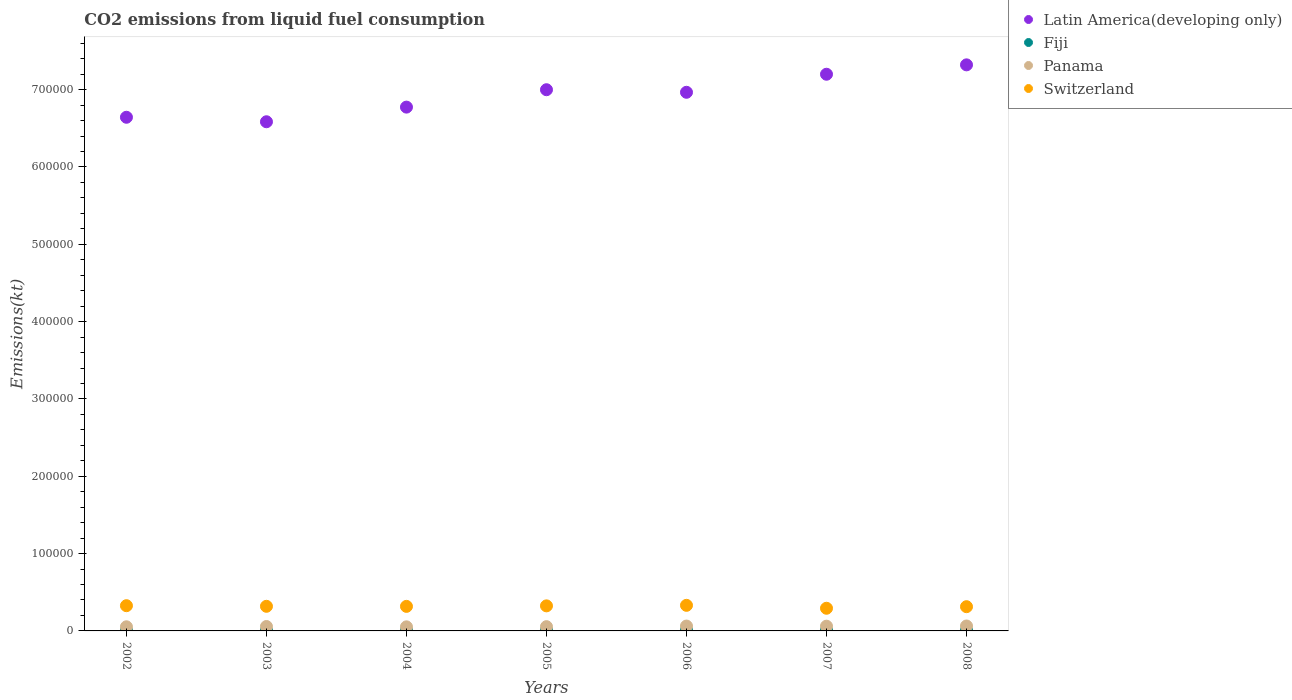How many different coloured dotlines are there?
Offer a terse response. 4. Is the number of dotlines equal to the number of legend labels?
Your response must be concise. Yes. What is the amount of CO2 emitted in Latin America(developing only) in 2003?
Make the answer very short. 6.58e+05. Across all years, what is the maximum amount of CO2 emitted in Panama?
Offer a terse response. 6380.58. Across all years, what is the minimum amount of CO2 emitted in Switzerland?
Ensure brevity in your answer.  2.93e+04. What is the total amount of CO2 emitted in Fiji in the graph?
Your answer should be compact. 7297.33. What is the difference between the amount of CO2 emitted in Fiji in 2002 and that in 2005?
Provide a succinct answer. -553.72. What is the difference between the amount of CO2 emitted in Switzerland in 2002 and the amount of CO2 emitted in Panama in 2005?
Your answer should be compact. 2.71e+04. What is the average amount of CO2 emitted in Switzerland per year?
Offer a very short reply. 3.18e+04. In the year 2003, what is the difference between the amount of CO2 emitted in Latin America(developing only) and amount of CO2 emitted in Fiji?
Ensure brevity in your answer.  6.58e+05. What is the ratio of the amount of CO2 emitted in Panama in 2002 to that in 2007?
Provide a short and direct response. 0.87. Is the amount of CO2 emitted in Switzerland in 2006 less than that in 2007?
Offer a terse response. No. Is the difference between the amount of CO2 emitted in Latin America(developing only) in 2002 and 2003 greater than the difference between the amount of CO2 emitted in Fiji in 2002 and 2003?
Your answer should be very brief. Yes. What is the difference between the highest and the second highest amount of CO2 emitted in Switzerland?
Offer a very short reply. 469.38. What is the difference between the highest and the lowest amount of CO2 emitted in Fiji?
Ensure brevity in your answer.  553.72. In how many years, is the amount of CO2 emitted in Latin America(developing only) greater than the average amount of CO2 emitted in Latin America(developing only) taken over all years?
Your answer should be very brief. 4. Is the sum of the amount of CO2 emitted in Panama in 2006 and 2007 greater than the maximum amount of CO2 emitted in Latin America(developing only) across all years?
Keep it short and to the point. No. Is it the case that in every year, the sum of the amount of CO2 emitted in Fiji and amount of CO2 emitted in Latin America(developing only)  is greater than the sum of amount of CO2 emitted in Panama and amount of CO2 emitted in Switzerland?
Your response must be concise. Yes. Does the amount of CO2 emitted in Switzerland monotonically increase over the years?
Your answer should be very brief. No. Is the amount of CO2 emitted in Panama strictly greater than the amount of CO2 emitted in Latin America(developing only) over the years?
Offer a terse response. No. How many dotlines are there?
Provide a succinct answer. 4. How many years are there in the graph?
Provide a short and direct response. 7. How many legend labels are there?
Provide a succinct answer. 4. What is the title of the graph?
Offer a very short reply. CO2 emissions from liquid fuel consumption. Does "Low & middle income" appear as one of the legend labels in the graph?
Your response must be concise. No. What is the label or title of the Y-axis?
Give a very brief answer. Emissions(kt). What is the Emissions(kt) of Latin America(developing only) in 2002?
Keep it short and to the point. 6.64e+05. What is the Emissions(kt) in Fiji in 2002?
Provide a succinct answer. 740.73. What is the Emissions(kt) of Panama in 2002?
Your answer should be very brief. 5342.82. What is the Emissions(kt) of Switzerland in 2002?
Offer a very short reply. 3.26e+04. What is the Emissions(kt) of Latin America(developing only) in 2003?
Keep it short and to the point. 6.58e+05. What is the Emissions(kt) in Fiji in 2003?
Provide a short and direct response. 759.07. What is the Emissions(kt) in Panama in 2003?
Ensure brevity in your answer.  5709.52. What is the Emissions(kt) of Switzerland in 2003?
Provide a succinct answer. 3.18e+04. What is the Emissions(kt) in Latin America(developing only) in 2004?
Provide a succinct answer. 6.77e+05. What is the Emissions(kt) of Fiji in 2004?
Your answer should be compact. 1074.43. What is the Emissions(kt) in Panama in 2004?
Provide a succinct answer. 5276.81. What is the Emissions(kt) of Switzerland in 2004?
Make the answer very short. 3.18e+04. What is the Emissions(kt) in Latin America(developing only) in 2005?
Offer a very short reply. 7.00e+05. What is the Emissions(kt) in Fiji in 2005?
Ensure brevity in your answer.  1294.45. What is the Emissions(kt) of Panama in 2005?
Your answer should be compact. 5507.83. What is the Emissions(kt) of Switzerland in 2005?
Offer a very short reply. 3.24e+04. What is the Emissions(kt) in Latin America(developing only) in 2006?
Your answer should be compact. 6.97e+05. What is the Emissions(kt) in Fiji in 2006?
Offer a very short reply. 1290.78. What is the Emissions(kt) of Panama in 2006?
Keep it short and to the point. 6299.91. What is the Emissions(kt) of Switzerland in 2006?
Give a very brief answer. 3.31e+04. What is the Emissions(kt) in Latin America(developing only) in 2007?
Keep it short and to the point. 7.20e+05. What is the Emissions(kt) of Fiji in 2007?
Your response must be concise. 1129.44. What is the Emissions(kt) in Panama in 2007?
Keep it short and to the point. 6138.56. What is the Emissions(kt) of Switzerland in 2007?
Give a very brief answer. 2.93e+04. What is the Emissions(kt) in Latin America(developing only) in 2008?
Your response must be concise. 7.32e+05. What is the Emissions(kt) in Fiji in 2008?
Your answer should be compact. 1008.42. What is the Emissions(kt) of Panama in 2008?
Your answer should be compact. 6380.58. What is the Emissions(kt) in Switzerland in 2008?
Give a very brief answer. 3.13e+04. Across all years, what is the maximum Emissions(kt) of Latin America(developing only)?
Your answer should be compact. 7.32e+05. Across all years, what is the maximum Emissions(kt) in Fiji?
Offer a very short reply. 1294.45. Across all years, what is the maximum Emissions(kt) in Panama?
Offer a terse response. 6380.58. Across all years, what is the maximum Emissions(kt) of Switzerland?
Keep it short and to the point. 3.31e+04. Across all years, what is the minimum Emissions(kt) in Latin America(developing only)?
Keep it short and to the point. 6.58e+05. Across all years, what is the minimum Emissions(kt) of Fiji?
Your response must be concise. 740.73. Across all years, what is the minimum Emissions(kt) of Panama?
Your answer should be compact. 5276.81. Across all years, what is the minimum Emissions(kt) in Switzerland?
Keep it short and to the point. 2.93e+04. What is the total Emissions(kt) in Latin America(developing only) in the graph?
Provide a short and direct response. 4.85e+06. What is the total Emissions(kt) of Fiji in the graph?
Offer a very short reply. 7297.33. What is the total Emissions(kt) in Panama in the graph?
Keep it short and to the point. 4.07e+04. What is the total Emissions(kt) in Switzerland in the graph?
Your answer should be very brief. 2.22e+05. What is the difference between the Emissions(kt) in Latin America(developing only) in 2002 and that in 2003?
Offer a terse response. 5823.2. What is the difference between the Emissions(kt) of Fiji in 2002 and that in 2003?
Give a very brief answer. -18.34. What is the difference between the Emissions(kt) in Panama in 2002 and that in 2003?
Your response must be concise. -366.7. What is the difference between the Emissions(kt) of Switzerland in 2002 and that in 2003?
Provide a succinct answer. 777.4. What is the difference between the Emissions(kt) of Latin America(developing only) in 2002 and that in 2004?
Offer a terse response. -1.31e+04. What is the difference between the Emissions(kt) in Fiji in 2002 and that in 2004?
Your response must be concise. -333.7. What is the difference between the Emissions(kt) of Panama in 2002 and that in 2004?
Provide a short and direct response. 66.01. What is the difference between the Emissions(kt) of Switzerland in 2002 and that in 2004?
Your response must be concise. 869.08. What is the difference between the Emissions(kt) of Latin America(developing only) in 2002 and that in 2005?
Provide a short and direct response. -3.56e+04. What is the difference between the Emissions(kt) of Fiji in 2002 and that in 2005?
Your answer should be compact. -553.72. What is the difference between the Emissions(kt) in Panama in 2002 and that in 2005?
Give a very brief answer. -165.01. What is the difference between the Emissions(kt) of Switzerland in 2002 and that in 2005?
Your answer should be very brief. 212.69. What is the difference between the Emissions(kt) in Latin America(developing only) in 2002 and that in 2006?
Your answer should be very brief. -3.23e+04. What is the difference between the Emissions(kt) of Fiji in 2002 and that in 2006?
Offer a terse response. -550.05. What is the difference between the Emissions(kt) of Panama in 2002 and that in 2006?
Provide a succinct answer. -957.09. What is the difference between the Emissions(kt) in Switzerland in 2002 and that in 2006?
Offer a very short reply. -469.38. What is the difference between the Emissions(kt) in Latin America(developing only) in 2002 and that in 2007?
Make the answer very short. -5.56e+04. What is the difference between the Emissions(kt) in Fiji in 2002 and that in 2007?
Your answer should be compact. -388.7. What is the difference between the Emissions(kt) of Panama in 2002 and that in 2007?
Give a very brief answer. -795.74. What is the difference between the Emissions(kt) of Switzerland in 2002 and that in 2007?
Provide a succinct answer. 3311.3. What is the difference between the Emissions(kt) of Latin America(developing only) in 2002 and that in 2008?
Offer a terse response. -6.78e+04. What is the difference between the Emissions(kt) in Fiji in 2002 and that in 2008?
Your answer should be very brief. -267.69. What is the difference between the Emissions(kt) of Panama in 2002 and that in 2008?
Make the answer very short. -1037.76. What is the difference between the Emissions(kt) in Switzerland in 2002 and that in 2008?
Your answer should be compact. 1279.78. What is the difference between the Emissions(kt) in Latin America(developing only) in 2003 and that in 2004?
Offer a terse response. -1.89e+04. What is the difference between the Emissions(kt) of Fiji in 2003 and that in 2004?
Offer a terse response. -315.36. What is the difference between the Emissions(kt) in Panama in 2003 and that in 2004?
Keep it short and to the point. 432.71. What is the difference between the Emissions(kt) of Switzerland in 2003 and that in 2004?
Offer a terse response. 91.67. What is the difference between the Emissions(kt) in Latin America(developing only) in 2003 and that in 2005?
Your answer should be compact. -4.14e+04. What is the difference between the Emissions(kt) of Fiji in 2003 and that in 2005?
Give a very brief answer. -535.38. What is the difference between the Emissions(kt) in Panama in 2003 and that in 2005?
Provide a succinct answer. 201.69. What is the difference between the Emissions(kt) in Switzerland in 2003 and that in 2005?
Keep it short and to the point. -564.72. What is the difference between the Emissions(kt) in Latin America(developing only) in 2003 and that in 2006?
Your answer should be compact. -3.81e+04. What is the difference between the Emissions(kt) in Fiji in 2003 and that in 2006?
Give a very brief answer. -531.72. What is the difference between the Emissions(kt) in Panama in 2003 and that in 2006?
Offer a very short reply. -590.39. What is the difference between the Emissions(kt) in Switzerland in 2003 and that in 2006?
Your answer should be compact. -1246.78. What is the difference between the Emissions(kt) of Latin America(developing only) in 2003 and that in 2007?
Offer a very short reply. -6.15e+04. What is the difference between the Emissions(kt) of Fiji in 2003 and that in 2007?
Provide a short and direct response. -370.37. What is the difference between the Emissions(kt) in Panama in 2003 and that in 2007?
Your answer should be compact. -429.04. What is the difference between the Emissions(kt) of Switzerland in 2003 and that in 2007?
Provide a succinct answer. 2533.9. What is the difference between the Emissions(kt) in Latin America(developing only) in 2003 and that in 2008?
Your answer should be very brief. -7.36e+04. What is the difference between the Emissions(kt) of Fiji in 2003 and that in 2008?
Keep it short and to the point. -249.36. What is the difference between the Emissions(kt) of Panama in 2003 and that in 2008?
Your response must be concise. -671.06. What is the difference between the Emissions(kt) of Switzerland in 2003 and that in 2008?
Offer a terse response. 502.38. What is the difference between the Emissions(kt) of Latin America(developing only) in 2004 and that in 2005?
Keep it short and to the point. -2.25e+04. What is the difference between the Emissions(kt) of Fiji in 2004 and that in 2005?
Offer a terse response. -220.02. What is the difference between the Emissions(kt) in Panama in 2004 and that in 2005?
Your answer should be very brief. -231.02. What is the difference between the Emissions(kt) of Switzerland in 2004 and that in 2005?
Make the answer very short. -656.39. What is the difference between the Emissions(kt) in Latin America(developing only) in 2004 and that in 2006?
Ensure brevity in your answer.  -1.92e+04. What is the difference between the Emissions(kt) of Fiji in 2004 and that in 2006?
Your answer should be compact. -216.35. What is the difference between the Emissions(kt) in Panama in 2004 and that in 2006?
Make the answer very short. -1023.09. What is the difference between the Emissions(kt) of Switzerland in 2004 and that in 2006?
Provide a succinct answer. -1338.45. What is the difference between the Emissions(kt) of Latin America(developing only) in 2004 and that in 2007?
Offer a very short reply. -4.25e+04. What is the difference between the Emissions(kt) of Fiji in 2004 and that in 2007?
Ensure brevity in your answer.  -55.01. What is the difference between the Emissions(kt) in Panama in 2004 and that in 2007?
Your response must be concise. -861.75. What is the difference between the Emissions(kt) in Switzerland in 2004 and that in 2007?
Your answer should be very brief. 2442.22. What is the difference between the Emissions(kt) in Latin America(developing only) in 2004 and that in 2008?
Your answer should be compact. -5.47e+04. What is the difference between the Emissions(kt) of Fiji in 2004 and that in 2008?
Keep it short and to the point. 66.01. What is the difference between the Emissions(kt) in Panama in 2004 and that in 2008?
Offer a terse response. -1103.77. What is the difference between the Emissions(kt) of Switzerland in 2004 and that in 2008?
Provide a short and direct response. 410.7. What is the difference between the Emissions(kt) of Latin America(developing only) in 2005 and that in 2006?
Provide a short and direct response. 3311.3. What is the difference between the Emissions(kt) of Fiji in 2005 and that in 2006?
Provide a short and direct response. 3.67. What is the difference between the Emissions(kt) of Panama in 2005 and that in 2006?
Give a very brief answer. -792.07. What is the difference between the Emissions(kt) in Switzerland in 2005 and that in 2006?
Offer a terse response. -682.06. What is the difference between the Emissions(kt) of Latin America(developing only) in 2005 and that in 2007?
Provide a succinct answer. -2.00e+04. What is the difference between the Emissions(kt) in Fiji in 2005 and that in 2007?
Your response must be concise. 165.01. What is the difference between the Emissions(kt) in Panama in 2005 and that in 2007?
Make the answer very short. -630.72. What is the difference between the Emissions(kt) of Switzerland in 2005 and that in 2007?
Your answer should be compact. 3098.61. What is the difference between the Emissions(kt) in Latin America(developing only) in 2005 and that in 2008?
Provide a succinct answer. -3.22e+04. What is the difference between the Emissions(kt) of Fiji in 2005 and that in 2008?
Ensure brevity in your answer.  286.03. What is the difference between the Emissions(kt) in Panama in 2005 and that in 2008?
Ensure brevity in your answer.  -872.75. What is the difference between the Emissions(kt) of Switzerland in 2005 and that in 2008?
Ensure brevity in your answer.  1067.1. What is the difference between the Emissions(kt) of Latin America(developing only) in 2006 and that in 2007?
Keep it short and to the point. -2.33e+04. What is the difference between the Emissions(kt) of Fiji in 2006 and that in 2007?
Ensure brevity in your answer.  161.35. What is the difference between the Emissions(kt) in Panama in 2006 and that in 2007?
Your response must be concise. 161.35. What is the difference between the Emissions(kt) in Switzerland in 2006 and that in 2007?
Give a very brief answer. 3780.68. What is the difference between the Emissions(kt) in Latin America(developing only) in 2006 and that in 2008?
Offer a very short reply. -3.55e+04. What is the difference between the Emissions(kt) in Fiji in 2006 and that in 2008?
Your response must be concise. 282.36. What is the difference between the Emissions(kt) in Panama in 2006 and that in 2008?
Make the answer very short. -80.67. What is the difference between the Emissions(kt) in Switzerland in 2006 and that in 2008?
Offer a very short reply. 1749.16. What is the difference between the Emissions(kt) in Latin America(developing only) in 2007 and that in 2008?
Your answer should be very brief. -1.21e+04. What is the difference between the Emissions(kt) of Fiji in 2007 and that in 2008?
Provide a succinct answer. 121.01. What is the difference between the Emissions(kt) in Panama in 2007 and that in 2008?
Give a very brief answer. -242.02. What is the difference between the Emissions(kt) of Switzerland in 2007 and that in 2008?
Your answer should be very brief. -2031.52. What is the difference between the Emissions(kt) of Latin America(developing only) in 2002 and the Emissions(kt) of Fiji in 2003?
Your answer should be very brief. 6.64e+05. What is the difference between the Emissions(kt) of Latin America(developing only) in 2002 and the Emissions(kt) of Panama in 2003?
Your response must be concise. 6.59e+05. What is the difference between the Emissions(kt) in Latin America(developing only) in 2002 and the Emissions(kt) in Switzerland in 2003?
Offer a very short reply. 6.32e+05. What is the difference between the Emissions(kt) of Fiji in 2002 and the Emissions(kt) of Panama in 2003?
Offer a terse response. -4968.78. What is the difference between the Emissions(kt) of Fiji in 2002 and the Emissions(kt) of Switzerland in 2003?
Offer a very short reply. -3.11e+04. What is the difference between the Emissions(kt) of Panama in 2002 and the Emissions(kt) of Switzerland in 2003?
Provide a short and direct response. -2.65e+04. What is the difference between the Emissions(kt) in Latin America(developing only) in 2002 and the Emissions(kt) in Fiji in 2004?
Your answer should be compact. 6.63e+05. What is the difference between the Emissions(kt) in Latin America(developing only) in 2002 and the Emissions(kt) in Panama in 2004?
Offer a terse response. 6.59e+05. What is the difference between the Emissions(kt) of Latin America(developing only) in 2002 and the Emissions(kt) of Switzerland in 2004?
Your response must be concise. 6.33e+05. What is the difference between the Emissions(kt) in Fiji in 2002 and the Emissions(kt) in Panama in 2004?
Provide a short and direct response. -4536.08. What is the difference between the Emissions(kt) of Fiji in 2002 and the Emissions(kt) of Switzerland in 2004?
Provide a succinct answer. -3.10e+04. What is the difference between the Emissions(kt) in Panama in 2002 and the Emissions(kt) in Switzerland in 2004?
Give a very brief answer. -2.64e+04. What is the difference between the Emissions(kt) in Latin America(developing only) in 2002 and the Emissions(kt) in Fiji in 2005?
Keep it short and to the point. 6.63e+05. What is the difference between the Emissions(kt) of Latin America(developing only) in 2002 and the Emissions(kt) of Panama in 2005?
Offer a terse response. 6.59e+05. What is the difference between the Emissions(kt) in Latin America(developing only) in 2002 and the Emissions(kt) in Switzerland in 2005?
Ensure brevity in your answer.  6.32e+05. What is the difference between the Emissions(kt) of Fiji in 2002 and the Emissions(kt) of Panama in 2005?
Offer a very short reply. -4767.1. What is the difference between the Emissions(kt) in Fiji in 2002 and the Emissions(kt) in Switzerland in 2005?
Make the answer very short. -3.17e+04. What is the difference between the Emissions(kt) of Panama in 2002 and the Emissions(kt) of Switzerland in 2005?
Make the answer very short. -2.71e+04. What is the difference between the Emissions(kt) in Latin America(developing only) in 2002 and the Emissions(kt) in Fiji in 2006?
Your answer should be compact. 6.63e+05. What is the difference between the Emissions(kt) of Latin America(developing only) in 2002 and the Emissions(kt) of Panama in 2006?
Make the answer very short. 6.58e+05. What is the difference between the Emissions(kt) of Latin America(developing only) in 2002 and the Emissions(kt) of Switzerland in 2006?
Make the answer very short. 6.31e+05. What is the difference between the Emissions(kt) of Fiji in 2002 and the Emissions(kt) of Panama in 2006?
Keep it short and to the point. -5559.17. What is the difference between the Emissions(kt) in Fiji in 2002 and the Emissions(kt) in Switzerland in 2006?
Your answer should be very brief. -3.24e+04. What is the difference between the Emissions(kt) in Panama in 2002 and the Emissions(kt) in Switzerland in 2006?
Keep it short and to the point. -2.77e+04. What is the difference between the Emissions(kt) of Latin America(developing only) in 2002 and the Emissions(kt) of Fiji in 2007?
Your response must be concise. 6.63e+05. What is the difference between the Emissions(kt) of Latin America(developing only) in 2002 and the Emissions(kt) of Panama in 2007?
Give a very brief answer. 6.58e+05. What is the difference between the Emissions(kt) in Latin America(developing only) in 2002 and the Emissions(kt) in Switzerland in 2007?
Keep it short and to the point. 6.35e+05. What is the difference between the Emissions(kt) in Fiji in 2002 and the Emissions(kt) in Panama in 2007?
Your answer should be compact. -5397.82. What is the difference between the Emissions(kt) in Fiji in 2002 and the Emissions(kt) in Switzerland in 2007?
Provide a succinct answer. -2.86e+04. What is the difference between the Emissions(kt) in Panama in 2002 and the Emissions(kt) in Switzerland in 2007?
Offer a very short reply. -2.40e+04. What is the difference between the Emissions(kt) in Latin America(developing only) in 2002 and the Emissions(kt) in Fiji in 2008?
Offer a very short reply. 6.63e+05. What is the difference between the Emissions(kt) of Latin America(developing only) in 2002 and the Emissions(kt) of Panama in 2008?
Offer a very short reply. 6.58e+05. What is the difference between the Emissions(kt) in Latin America(developing only) in 2002 and the Emissions(kt) in Switzerland in 2008?
Provide a succinct answer. 6.33e+05. What is the difference between the Emissions(kt) of Fiji in 2002 and the Emissions(kt) of Panama in 2008?
Ensure brevity in your answer.  -5639.85. What is the difference between the Emissions(kt) of Fiji in 2002 and the Emissions(kt) of Switzerland in 2008?
Your response must be concise. -3.06e+04. What is the difference between the Emissions(kt) of Panama in 2002 and the Emissions(kt) of Switzerland in 2008?
Your answer should be very brief. -2.60e+04. What is the difference between the Emissions(kt) in Latin America(developing only) in 2003 and the Emissions(kt) in Fiji in 2004?
Keep it short and to the point. 6.57e+05. What is the difference between the Emissions(kt) in Latin America(developing only) in 2003 and the Emissions(kt) in Panama in 2004?
Keep it short and to the point. 6.53e+05. What is the difference between the Emissions(kt) of Latin America(developing only) in 2003 and the Emissions(kt) of Switzerland in 2004?
Keep it short and to the point. 6.27e+05. What is the difference between the Emissions(kt) of Fiji in 2003 and the Emissions(kt) of Panama in 2004?
Offer a terse response. -4517.74. What is the difference between the Emissions(kt) of Fiji in 2003 and the Emissions(kt) of Switzerland in 2004?
Make the answer very short. -3.10e+04. What is the difference between the Emissions(kt) in Panama in 2003 and the Emissions(kt) in Switzerland in 2004?
Make the answer very short. -2.60e+04. What is the difference between the Emissions(kt) of Latin America(developing only) in 2003 and the Emissions(kt) of Fiji in 2005?
Give a very brief answer. 6.57e+05. What is the difference between the Emissions(kt) in Latin America(developing only) in 2003 and the Emissions(kt) in Panama in 2005?
Offer a very short reply. 6.53e+05. What is the difference between the Emissions(kt) in Latin America(developing only) in 2003 and the Emissions(kt) in Switzerland in 2005?
Ensure brevity in your answer.  6.26e+05. What is the difference between the Emissions(kt) in Fiji in 2003 and the Emissions(kt) in Panama in 2005?
Your answer should be compact. -4748.77. What is the difference between the Emissions(kt) of Fiji in 2003 and the Emissions(kt) of Switzerland in 2005?
Your answer should be very brief. -3.16e+04. What is the difference between the Emissions(kt) in Panama in 2003 and the Emissions(kt) in Switzerland in 2005?
Your answer should be very brief. -2.67e+04. What is the difference between the Emissions(kt) of Latin America(developing only) in 2003 and the Emissions(kt) of Fiji in 2006?
Your answer should be compact. 6.57e+05. What is the difference between the Emissions(kt) of Latin America(developing only) in 2003 and the Emissions(kt) of Panama in 2006?
Your answer should be very brief. 6.52e+05. What is the difference between the Emissions(kt) of Latin America(developing only) in 2003 and the Emissions(kt) of Switzerland in 2006?
Your answer should be very brief. 6.25e+05. What is the difference between the Emissions(kt) in Fiji in 2003 and the Emissions(kt) in Panama in 2006?
Your answer should be compact. -5540.84. What is the difference between the Emissions(kt) of Fiji in 2003 and the Emissions(kt) of Switzerland in 2006?
Keep it short and to the point. -3.23e+04. What is the difference between the Emissions(kt) of Panama in 2003 and the Emissions(kt) of Switzerland in 2006?
Give a very brief answer. -2.74e+04. What is the difference between the Emissions(kt) of Latin America(developing only) in 2003 and the Emissions(kt) of Fiji in 2007?
Offer a very short reply. 6.57e+05. What is the difference between the Emissions(kt) of Latin America(developing only) in 2003 and the Emissions(kt) of Panama in 2007?
Offer a terse response. 6.52e+05. What is the difference between the Emissions(kt) in Latin America(developing only) in 2003 and the Emissions(kt) in Switzerland in 2007?
Offer a very short reply. 6.29e+05. What is the difference between the Emissions(kt) in Fiji in 2003 and the Emissions(kt) in Panama in 2007?
Your answer should be compact. -5379.49. What is the difference between the Emissions(kt) in Fiji in 2003 and the Emissions(kt) in Switzerland in 2007?
Offer a very short reply. -2.86e+04. What is the difference between the Emissions(kt) of Panama in 2003 and the Emissions(kt) of Switzerland in 2007?
Make the answer very short. -2.36e+04. What is the difference between the Emissions(kt) in Latin America(developing only) in 2003 and the Emissions(kt) in Fiji in 2008?
Provide a short and direct response. 6.57e+05. What is the difference between the Emissions(kt) in Latin America(developing only) in 2003 and the Emissions(kt) in Panama in 2008?
Provide a short and direct response. 6.52e+05. What is the difference between the Emissions(kt) of Latin America(developing only) in 2003 and the Emissions(kt) of Switzerland in 2008?
Offer a very short reply. 6.27e+05. What is the difference between the Emissions(kt) of Fiji in 2003 and the Emissions(kt) of Panama in 2008?
Your response must be concise. -5621.51. What is the difference between the Emissions(kt) of Fiji in 2003 and the Emissions(kt) of Switzerland in 2008?
Keep it short and to the point. -3.06e+04. What is the difference between the Emissions(kt) of Panama in 2003 and the Emissions(kt) of Switzerland in 2008?
Make the answer very short. -2.56e+04. What is the difference between the Emissions(kt) of Latin America(developing only) in 2004 and the Emissions(kt) of Fiji in 2005?
Your answer should be compact. 6.76e+05. What is the difference between the Emissions(kt) of Latin America(developing only) in 2004 and the Emissions(kt) of Panama in 2005?
Your response must be concise. 6.72e+05. What is the difference between the Emissions(kt) in Latin America(developing only) in 2004 and the Emissions(kt) in Switzerland in 2005?
Provide a short and direct response. 6.45e+05. What is the difference between the Emissions(kt) in Fiji in 2004 and the Emissions(kt) in Panama in 2005?
Ensure brevity in your answer.  -4433.4. What is the difference between the Emissions(kt) of Fiji in 2004 and the Emissions(kt) of Switzerland in 2005?
Offer a terse response. -3.13e+04. What is the difference between the Emissions(kt) in Panama in 2004 and the Emissions(kt) in Switzerland in 2005?
Offer a terse response. -2.71e+04. What is the difference between the Emissions(kt) in Latin America(developing only) in 2004 and the Emissions(kt) in Fiji in 2006?
Provide a short and direct response. 6.76e+05. What is the difference between the Emissions(kt) in Latin America(developing only) in 2004 and the Emissions(kt) in Panama in 2006?
Your answer should be compact. 6.71e+05. What is the difference between the Emissions(kt) in Latin America(developing only) in 2004 and the Emissions(kt) in Switzerland in 2006?
Your answer should be compact. 6.44e+05. What is the difference between the Emissions(kt) in Fiji in 2004 and the Emissions(kt) in Panama in 2006?
Keep it short and to the point. -5225.48. What is the difference between the Emissions(kt) of Fiji in 2004 and the Emissions(kt) of Switzerland in 2006?
Provide a succinct answer. -3.20e+04. What is the difference between the Emissions(kt) of Panama in 2004 and the Emissions(kt) of Switzerland in 2006?
Your answer should be compact. -2.78e+04. What is the difference between the Emissions(kt) of Latin America(developing only) in 2004 and the Emissions(kt) of Fiji in 2007?
Ensure brevity in your answer.  6.76e+05. What is the difference between the Emissions(kt) in Latin America(developing only) in 2004 and the Emissions(kt) in Panama in 2007?
Provide a succinct answer. 6.71e+05. What is the difference between the Emissions(kt) of Latin America(developing only) in 2004 and the Emissions(kt) of Switzerland in 2007?
Offer a terse response. 6.48e+05. What is the difference between the Emissions(kt) in Fiji in 2004 and the Emissions(kt) in Panama in 2007?
Give a very brief answer. -5064.13. What is the difference between the Emissions(kt) of Fiji in 2004 and the Emissions(kt) of Switzerland in 2007?
Keep it short and to the point. -2.82e+04. What is the difference between the Emissions(kt) of Panama in 2004 and the Emissions(kt) of Switzerland in 2007?
Ensure brevity in your answer.  -2.40e+04. What is the difference between the Emissions(kt) in Latin America(developing only) in 2004 and the Emissions(kt) in Fiji in 2008?
Offer a terse response. 6.76e+05. What is the difference between the Emissions(kt) in Latin America(developing only) in 2004 and the Emissions(kt) in Panama in 2008?
Provide a succinct answer. 6.71e+05. What is the difference between the Emissions(kt) of Latin America(developing only) in 2004 and the Emissions(kt) of Switzerland in 2008?
Keep it short and to the point. 6.46e+05. What is the difference between the Emissions(kt) of Fiji in 2004 and the Emissions(kt) of Panama in 2008?
Ensure brevity in your answer.  -5306.15. What is the difference between the Emissions(kt) of Fiji in 2004 and the Emissions(kt) of Switzerland in 2008?
Make the answer very short. -3.03e+04. What is the difference between the Emissions(kt) in Panama in 2004 and the Emissions(kt) in Switzerland in 2008?
Keep it short and to the point. -2.61e+04. What is the difference between the Emissions(kt) in Latin America(developing only) in 2005 and the Emissions(kt) in Fiji in 2006?
Offer a terse response. 6.99e+05. What is the difference between the Emissions(kt) of Latin America(developing only) in 2005 and the Emissions(kt) of Panama in 2006?
Provide a succinct answer. 6.94e+05. What is the difference between the Emissions(kt) in Latin America(developing only) in 2005 and the Emissions(kt) in Switzerland in 2006?
Ensure brevity in your answer.  6.67e+05. What is the difference between the Emissions(kt) in Fiji in 2005 and the Emissions(kt) in Panama in 2006?
Ensure brevity in your answer.  -5005.45. What is the difference between the Emissions(kt) in Fiji in 2005 and the Emissions(kt) in Switzerland in 2006?
Give a very brief answer. -3.18e+04. What is the difference between the Emissions(kt) of Panama in 2005 and the Emissions(kt) of Switzerland in 2006?
Offer a terse response. -2.76e+04. What is the difference between the Emissions(kt) in Latin America(developing only) in 2005 and the Emissions(kt) in Fiji in 2007?
Your answer should be compact. 6.99e+05. What is the difference between the Emissions(kt) of Latin America(developing only) in 2005 and the Emissions(kt) of Panama in 2007?
Provide a succinct answer. 6.94e+05. What is the difference between the Emissions(kt) in Latin America(developing only) in 2005 and the Emissions(kt) in Switzerland in 2007?
Provide a succinct answer. 6.71e+05. What is the difference between the Emissions(kt) of Fiji in 2005 and the Emissions(kt) of Panama in 2007?
Your response must be concise. -4844.11. What is the difference between the Emissions(kt) in Fiji in 2005 and the Emissions(kt) in Switzerland in 2007?
Your answer should be very brief. -2.80e+04. What is the difference between the Emissions(kt) of Panama in 2005 and the Emissions(kt) of Switzerland in 2007?
Your answer should be very brief. -2.38e+04. What is the difference between the Emissions(kt) in Latin America(developing only) in 2005 and the Emissions(kt) in Fiji in 2008?
Your response must be concise. 6.99e+05. What is the difference between the Emissions(kt) of Latin America(developing only) in 2005 and the Emissions(kt) of Panama in 2008?
Your answer should be compact. 6.93e+05. What is the difference between the Emissions(kt) in Latin America(developing only) in 2005 and the Emissions(kt) in Switzerland in 2008?
Offer a very short reply. 6.69e+05. What is the difference between the Emissions(kt) of Fiji in 2005 and the Emissions(kt) of Panama in 2008?
Give a very brief answer. -5086.13. What is the difference between the Emissions(kt) in Fiji in 2005 and the Emissions(kt) in Switzerland in 2008?
Provide a succinct answer. -3.00e+04. What is the difference between the Emissions(kt) of Panama in 2005 and the Emissions(kt) of Switzerland in 2008?
Keep it short and to the point. -2.58e+04. What is the difference between the Emissions(kt) in Latin America(developing only) in 2006 and the Emissions(kt) in Fiji in 2007?
Provide a succinct answer. 6.95e+05. What is the difference between the Emissions(kt) in Latin America(developing only) in 2006 and the Emissions(kt) in Panama in 2007?
Make the answer very short. 6.90e+05. What is the difference between the Emissions(kt) in Latin America(developing only) in 2006 and the Emissions(kt) in Switzerland in 2007?
Offer a very short reply. 6.67e+05. What is the difference between the Emissions(kt) of Fiji in 2006 and the Emissions(kt) of Panama in 2007?
Give a very brief answer. -4847.77. What is the difference between the Emissions(kt) in Fiji in 2006 and the Emissions(kt) in Switzerland in 2007?
Your answer should be very brief. -2.80e+04. What is the difference between the Emissions(kt) of Panama in 2006 and the Emissions(kt) of Switzerland in 2007?
Provide a short and direct response. -2.30e+04. What is the difference between the Emissions(kt) of Latin America(developing only) in 2006 and the Emissions(kt) of Fiji in 2008?
Your response must be concise. 6.96e+05. What is the difference between the Emissions(kt) in Latin America(developing only) in 2006 and the Emissions(kt) in Panama in 2008?
Your response must be concise. 6.90e+05. What is the difference between the Emissions(kt) in Latin America(developing only) in 2006 and the Emissions(kt) in Switzerland in 2008?
Your answer should be very brief. 6.65e+05. What is the difference between the Emissions(kt) of Fiji in 2006 and the Emissions(kt) of Panama in 2008?
Keep it short and to the point. -5089.8. What is the difference between the Emissions(kt) in Fiji in 2006 and the Emissions(kt) in Switzerland in 2008?
Keep it short and to the point. -3.01e+04. What is the difference between the Emissions(kt) in Panama in 2006 and the Emissions(kt) in Switzerland in 2008?
Provide a short and direct response. -2.50e+04. What is the difference between the Emissions(kt) in Latin America(developing only) in 2007 and the Emissions(kt) in Fiji in 2008?
Give a very brief answer. 7.19e+05. What is the difference between the Emissions(kt) of Latin America(developing only) in 2007 and the Emissions(kt) of Panama in 2008?
Keep it short and to the point. 7.14e+05. What is the difference between the Emissions(kt) of Latin America(developing only) in 2007 and the Emissions(kt) of Switzerland in 2008?
Offer a terse response. 6.89e+05. What is the difference between the Emissions(kt) in Fiji in 2007 and the Emissions(kt) in Panama in 2008?
Offer a very short reply. -5251.14. What is the difference between the Emissions(kt) in Fiji in 2007 and the Emissions(kt) in Switzerland in 2008?
Your response must be concise. -3.02e+04. What is the difference between the Emissions(kt) of Panama in 2007 and the Emissions(kt) of Switzerland in 2008?
Offer a terse response. -2.52e+04. What is the average Emissions(kt) of Latin America(developing only) per year?
Offer a very short reply. 6.93e+05. What is the average Emissions(kt) of Fiji per year?
Offer a very short reply. 1042.48. What is the average Emissions(kt) in Panama per year?
Provide a succinct answer. 5808. What is the average Emissions(kt) in Switzerland per year?
Your answer should be very brief. 3.18e+04. In the year 2002, what is the difference between the Emissions(kt) of Latin America(developing only) and Emissions(kt) of Fiji?
Provide a short and direct response. 6.64e+05. In the year 2002, what is the difference between the Emissions(kt) of Latin America(developing only) and Emissions(kt) of Panama?
Provide a succinct answer. 6.59e+05. In the year 2002, what is the difference between the Emissions(kt) in Latin America(developing only) and Emissions(kt) in Switzerland?
Offer a terse response. 6.32e+05. In the year 2002, what is the difference between the Emissions(kt) in Fiji and Emissions(kt) in Panama?
Give a very brief answer. -4602.09. In the year 2002, what is the difference between the Emissions(kt) in Fiji and Emissions(kt) in Switzerland?
Provide a succinct answer. -3.19e+04. In the year 2002, what is the difference between the Emissions(kt) in Panama and Emissions(kt) in Switzerland?
Provide a short and direct response. -2.73e+04. In the year 2003, what is the difference between the Emissions(kt) in Latin America(developing only) and Emissions(kt) in Fiji?
Provide a short and direct response. 6.58e+05. In the year 2003, what is the difference between the Emissions(kt) in Latin America(developing only) and Emissions(kt) in Panama?
Offer a very short reply. 6.53e+05. In the year 2003, what is the difference between the Emissions(kt) of Latin America(developing only) and Emissions(kt) of Switzerland?
Give a very brief answer. 6.27e+05. In the year 2003, what is the difference between the Emissions(kt) in Fiji and Emissions(kt) in Panama?
Your response must be concise. -4950.45. In the year 2003, what is the difference between the Emissions(kt) in Fiji and Emissions(kt) in Switzerland?
Keep it short and to the point. -3.11e+04. In the year 2003, what is the difference between the Emissions(kt) in Panama and Emissions(kt) in Switzerland?
Ensure brevity in your answer.  -2.61e+04. In the year 2004, what is the difference between the Emissions(kt) of Latin America(developing only) and Emissions(kt) of Fiji?
Make the answer very short. 6.76e+05. In the year 2004, what is the difference between the Emissions(kt) in Latin America(developing only) and Emissions(kt) in Panama?
Give a very brief answer. 6.72e+05. In the year 2004, what is the difference between the Emissions(kt) in Latin America(developing only) and Emissions(kt) in Switzerland?
Your response must be concise. 6.46e+05. In the year 2004, what is the difference between the Emissions(kt) in Fiji and Emissions(kt) in Panama?
Give a very brief answer. -4202.38. In the year 2004, what is the difference between the Emissions(kt) of Fiji and Emissions(kt) of Switzerland?
Offer a terse response. -3.07e+04. In the year 2004, what is the difference between the Emissions(kt) in Panama and Emissions(kt) in Switzerland?
Your answer should be very brief. -2.65e+04. In the year 2005, what is the difference between the Emissions(kt) of Latin America(developing only) and Emissions(kt) of Fiji?
Ensure brevity in your answer.  6.99e+05. In the year 2005, what is the difference between the Emissions(kt) in Latin America(developing only) and Emissions(kt) in Panama?
Your response must be concise. 6.94e+05. In the year 2005, what is the difference between the Emissions(kt) in Latin America(developing only) and Emissions(kt) in Switzerland?
Your response must be concise. 6.67e+05. In the year 2005, what is the difference between the Emissions(kt) of Fiji and Emissions(kt) of Panama?
Offer a very short reply. -4213.38. In the year 2005, what is the difference between the Emissions(kt) of Fiji and Emissions(kt) of Switzerland?
Offer a very short reply. -3.11e+04. In the year 2005, what is the difference between the Emissions(kt) of Panama and Emissions(kt) of Switzerland?
Offer a very short reply. -2.69e+04. In the year 2006, what is the difference between the Emissions(kt) in Latin America(developing only) and Emissions(kt) in Fiji?
Offer a terse response. 6.95e+05. In the year 2006, what is the difference between the Emissions(kt) in Latin America(developing only) and Emissions(kt) in Panama?
Offer a terse response. 6.90e+05. In the year 2006, what is the difference between the Emissions(kt) of Latin America(developing only) and Emissions(kt) of Switzerland?
Keep it short and to the point. 6.63e+05. In the year 2006, what is the difference between the Emissions(kt) in Fiji and Emissions(kt) in Panama?
Your answer should be very brief. -5009.12. In the year 2006, what is the difference between the Emissions(kt) in Fiji and Emissions(kt) in Switzerland?
Provide a short and direct response. -3.18e+04. In the year 2006, what is the difference between the Emissions(kt) of Panama and Emissions(kt) of Switzerland?
Your response must be concise. -2.68e+04. In the year 2007, what is the difference between the Emissions(kt) in Latin America(developing only) and Emissions(kt) in Fiji?
Give a very brief answer. 7.19e+05. In the year 2007, what is the difference between the Emissions(kt) of Latin America(developing only) and Emissions(kt) of Panama?
Give a very brief answer. 7.14e+05. In the year 2007, what is the difference between the Emissions(kt) of Latin America(developing only) and Emissions(kt) of Switzerland?
Provide a short and direct response. 6.91e+05. In the year 2007, what is the difference between the Emissions(kt) in Fiji and Emissions(kt) in Panama?
Offer a very short reply. -5009.12. In the year 2007, what is the difference between the Emissions(kt) of Fiji and Emissions(kt) of Switzerland?
Give a very brief answer. -2.82e+04. In the year 2007, what is the difference between the Emissions(kt) in Panama and Emissions(kt) in Switzerland?
Your response must be concise. -2.32e+04. In the year 2008, what is the difference between the Emissions(kt) in Latin America(developing only) and Emissions(kt) in Fiji?
Make the answer very short. 7.31e+05. In the year 2008, what is the difference between the Emissions(kt) of Latin America(developing only) and Emissions(kt) of Panama?
Your answer should be compact. 7.26e+05. In the year 2008, what is the difference between the Emissions(kt) of Latin America(developing only) and Emissions(kt) of Switzerland?
Offer a very short reply. 7.01e+05. In the year 2008, what is the difference between the Emissions(kt) of Fiji and Emissions(kt) of Panama?
Give a very brief answer. -5372.15. In the year 2008, what is the difference between the Emissions(kt) of Fiji and Emissions(kt) of Switzerland?
Make the answer very short. -3.03e+04. In the year 2008, what is the difference between the Emissions(kt) of Panama and Emissions(kt) of Switzerland?
Provide a succinct answer. -2.50e+04. What is the ratio of the Emissions(kt) in Latin America(developing only) in 2002 to that in 2003?
Provide a short and direct response. 1.01. What is the ratio of the Emissions(kt) in Fiji in 2002 to that in 2003?
Keep it short and to the point. 0.98. What is the ratio of the Emissions(kt) in Panama in 2002 to that in 2003?
Your answer should be very brief. 0.94. What is the ratio of the Emissions(kt) in Switzerland in 2002 to that in 2003?
Provide a succinct answer. 1.02. What is the ratio of the Emissions(kt) in Latin America(developing only) in 2002 to that in 2004?
Your answer should be compact. 0.98. What is the ratio of the Emissions(kt) of Fiji in 2002 to that in 2004?
Make the answer very short. 0.69. What is the ratio of the Emissions(kt) of Panama in 2002 to that in 2004?
Keep it short and to the point. 1.01. What is the ratio of the Emissions(kt) in Switzerland in 2002 to that in 2004?
Provide a succinct answer. 1.03. What is the ratio of the Emissions(kt) of Latin America(developing only) in 2002 to that in 2005?
Offer a very short reply. 0.95. What is the ratio of the Emissions(kt) of Fiji in 2002 to that in 2005?
Your response must be concise. 0.57. What is the ratio of the Emissions(kt) in Switzerland in 2002 to that in 2005?
Your answer should be very brief. 1.01. What is the ratio of the Emissions(kt) of Latin America(developing only) in 2002 to that in 2006?
Your response must be concise. 0.95. What is the ratio of the Emissions(kt) of Fiji in 2002 to that in 2006?
Make the answer very short. 0.57. What is the ratio of the Emissions(kt) in Panama in 2002 to that in 2006?
Provide a succinct answer. 0.85. What is the ratio of the Emissions(kt) in Switzerland in 2002 to that in 2006?
Offer a terse response. 0.99. What is the ratio of the Emissions(kt) of Latin America(developing only) in 2002 to that in 2007?
Make the answer very short. 0.92. What is the ratio of the Emissions(kt) of Fiji in 2002 to that in 2007?
Make the answer very short. 0.66. What is the ratio of the Emissions(kt) of Panama in 2002 to that in 2007?
Make the answer very short. 0.87. What is the ratio of the Emissions(kt) in Switzerland in 2002 to that in 2007?
Ensure brevity in your answer.  1.11. What is the ratio of the Emissions(kt) of Latin America(developing only) in 2002 to that in 2008?
Your answer should be very brief. 0.91. What is the ratio of the Emissions(kt) in Fiji in 2002 to that in 2008?
Offer a terse response. 0.73. What is the ratio of the Emissions(kt) in Panama in 2002 to that in 2008?
Provide a short and direct response. 0.84. What is the ratio of the Emissions(kt) in Switzerland in 2002 to that in 2008?
Give a very brief answer. 1.04. What is the ratio of the Emissions(kt) in Fiji in 2003 to that in 2004?
Your answer should be compact. 0.71. What is the ratio of the Emissions(kt) in Panama in 2003 to that in 2004?
Provide a short and direct response. 1.08. What is the ratio of the Emissions(kt) in Switzerland in 2003 to that in 2004?
Ensure brevity in your answer.  1. What is the ratio of the Emissions(kt) in Latin America(developing only) in 2003 to that in 2005?
Your answer should be compact. 0.94. What is the ratio of the Emissions(kt) of Fiji in 2003 to that in 2005?
Your answer should be compact. 0.59. What is the ratio of the Emissions(kt) of Panama in 2003 to that in 2005?
Offer a very short reply. 1.04. What is the ratio of the Emissions(kt) in Switzerland in 2003 to that in 2005?
Offer a terse response. 0.98. What is the ratio of the Emissions(kt) of Latin America(developing only) in 2003 to that in 2006?
Offer a terse response. 0.95. What is the ratio of the Emissions(kt) in Fiji in 2003 to that in 2006?
Your answer should be compact. 0.59. What is the ratio of the Emissions(kt) of Panama in 2003 to that in 2006?
Ensure brevity in your answer.  0.91. What is the ratio of the Emissions(kt) of Switzerland in 2003 to that in 2006?
Provide a succinct answer. 0.96. What is the ratio of the Emissions(kt) of Latin America(developing only) in 2003 to that in 2007?
Offer a very short reply. 0.91. What is the ratio of the Emissions(kt) in Fiji in 2003 to that in 2007?
Ensure brevity in your answer.  0.67. What is the ratio of the Emissions(kt) of Panama in 2003 to that in 2007?
Keep it short and to the point. 0.93. What is the ratio of the Emissions(kt) of Switzerland in 2003 to that in 2007?
Your answer should be compact. 1.09. What is the ratio of the Emissions(kt) in Latin America(developing only) in 2003 to that in 2008?
Your answer should be compact. 0.9. What is the ratio of the Emissions(kt) in Fiji in 2003 to that in 2008?
Provide a short and direct response. 0.75. What is the ratio of the Emissions(kt) of Panama in 2003 to that in 2008?
Offer a terse response. 0.89. What is the ratio of the Emissions(kt) in Switzerland in 2003 to that in 2008?
Provide a succinct answer. 1.02. What is the ratio of the Emissions(kt) in Latin America(developing only) in 2004 to that in 2005?
Give a very brief answer. 0.97. What is the ratio of the Emissions(kt) of Fiji in 2004 to that in 2005?
Your answer should be very brief. 0.83. What is the ratio of the Emissions(kt) in Panama in 2004 to that in 2005?
Provide a succinct answer. 0.96. What is the ratio of the Emissions(kt) of Switzerland in 2004 to that in 2005?
Provide a short and direct response. 0.98. What is the ratio of the Emissions(kt) in Latin America(developing only) in 2004 to that in 2006?
Offer a very short reply. 0.97. What is the ratio of the Emissions(kt) of Fiji in 2004 to that in 2006?
Keep it short and to the point. 0.83. What is the ratio of the Emissions(kt) in Panama in 2004 to that in 2006?
Make the answer very short. 0.84. What is the ratio of the Emissions(kt) of Switzerland in 2004 to that in 2006?
Provide a succinct answer. 0.96. What is the ratio of the Emissions(kt) in Latin America(developing only) in 2004 to that in 2007?
Provide a short and direct response. 0.94. What is the ratio of the Emissions(kt) in Fiji in 2004 to that in 2007?
Your answer should be very brief. 0.95. What is the ratio of the Emissions(kt) in Panama in 2004 to that in 2007?
Make the answer very short. 0.86. What is the ratio of the Emissions(kt) of Switzerland in 2004 to that in 2007?
Offer a terse response. 1.08. What is the ratio of the Emissions(kt) of Latin America(developing only) in 2004 to that in 2008?
Your answer should be very brief. 0.93. What is the ratio of the Emissions(kt) of Fiji in 2004 to that in 2008?
Make the answer very short. 1.07. What is the ratio of the Emissions(kt) in Panama in 2004 to that in 2008?
Keep it short and to the point. 0.83. What is the ratio of the Emissions(kt) of Switzerland in 2004 to that in 2008?
Your response must be concise. 1.01. What is the ratio of the Emissions(kt) of Panama in 2005 to that in 2006?
Your answer should be very brief. 0.87. What is the ratio of the Emissions(kt) in Switzerland in 2005 to that in 2006?
Make the answer very short. 0.98. What is the ratio of the Emissions(kt) of Latin America(developing only) in 2005 to that in 2007?
Offer a terse response. 0.97. What is the ratio of the Emissions(kt) in Fiji in 2005 to that in 2007?
Keep it short and to the point. 1.15. What is the ratio of the Emissions(kt) in Panama in 2005 to that in 2007?
Keep it short and to the point. 0.9. What is the ratio of the Emissions(kt) of Switzerland in 2005 to that in 2007?
Your response must be concise. 1.11. What is the ratio of the Emissions(kt) in Latin America(developing only) in 2005 to that in 2008?
Offer a terse response. 0.96. What is the ratio of the Emissions(kt) in Fiji in 2005 to that in 2008?
Offer a terse response. 1.28. What is the ratio of the Emissions(kt) of Panama in 2005 to that in 2008?
Your answer should be very brief. 0.86. What is the ratio of the Emissions(kt) of Switzerland in 2005 to that in 2008?
Keep it short and to the point. 1.03. What is the ratio of the Emissions(kt) of Latin America(developing only) in 2006 to that in 2007?
Your response must be concise. 0.97. What is the ratio of the Emissions(kt) of Panama in 2006 to that in 2007?
Provide a succinct answer. 1.03. What is the ratio of the Emissions(kt) in Switzerland in 2006 to that in 2007?
Offer a terse response. 1.13. What is the ratio of the Emissions(kt) of Latin America(developing only) in 2006 to that in 2008?
Your response must be concise. 0.95. What is the ratio of the Emissions(kt) in Fiji in 2006 to that in 2008?
Your answer should be very brief. 1.28. What is the ratio of the Emissions(kt) of Panama in 2006 to that in 2008?
Offer a terse response. 0.99. What is the ratio of the Emissions(kt) of Switzerland in 2006 to that in 2008?
Offer a terse response. 1.06. What is the ratio of the Emissions(kt) of Latin America(developing only) in 2007 to that in 2008?
Offer a very short reply. 0.98. What is the ratio of the Emissions(kt) of Fiji in 2007 to that in 2008?
Ensure brevity in your answer.  1.12. What is the ratio of the Emissions(kt) in Panama in 2007 to that in 2008?
Your answer should be very brief. 0.96. What is the ratio of the Emissions(kt) in Switzerland in 2007 to that in 2008?
Your answer should be compact. 0.94. What is the difference between the highest and the second highest Emissions(kt) in Latin America(developing only)?
Ensure brevity in your answer.  1.21e+04. What is the difference between the highest and the second highest Emissions(kt) of Fiji?
Offer a terse response. 3.67. What is the difference between the highest and the second highest Emissions(kt) of Panama?
Provide a succinct answer. 80.67. What is the difference between the highest and the second highest Emissions(kt) in Switzerland?
Provide a succinct answer. 469.38. What is the difference between the highest and the lowest Emissions(kt) of Latin America(developing only)?
Ensure brevity in your answer.  7.36e+04. What is the difference between the highest and the lowest Emissions(kt) of Fiji?
Make the answer very short. 553.72. What is the difference between the highest and the lowest Emissions(kt) in Panama?
Keep it short and to the point. 1103.77. What is the difference between the highest and the lowest Emissions(kt) in Switzerland?
Make the answer very short. 3780.68. 